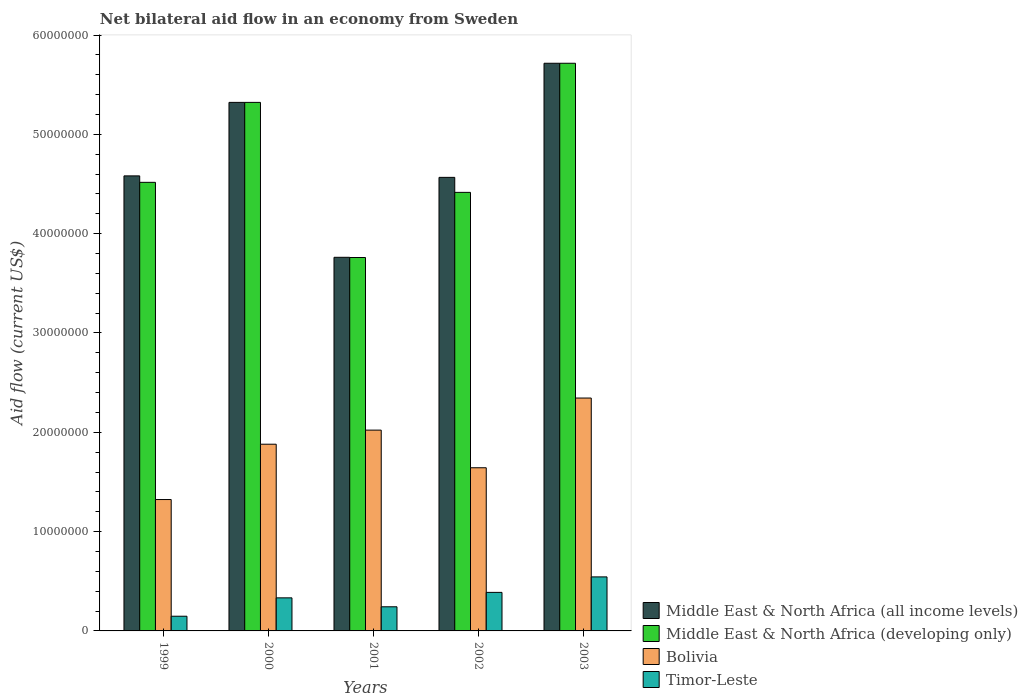How many groups of bars are there?
Make the answer very short. 5. Are the number of bars per tick equal to the number of legend labels?
Ensure brevity in your answer.  Yes. Are the number of bars on each tick of the X-axis equal?
Ensure brevity in your answer.  Yes. How many bars are there on the 3rd tick from the left?
Provide a succinct answer. 4. How many bars are there on the 5th tick from the right?
Keep it short and to the point. 4. What is the label of the 1st group of bars from the left?
Your answer should be very brief. 1999. What is the net bilateral aid flow in Timor-Leste in 2000?
Offer a terse response. 3.33e+06. Across all years, what is the maximum net bilateral aid flow in Bolivia?
Ensure brevity in your answer.  2.34e+07. Across all years, what is the minimum net bilateral aid flow in Timor-Leste?
Your response must be concise. 1.48e+06. What is the total net bilateral aid flow in Middle East & North Africa (developing only) in the graph?
Provide a succinct answer. 2.37e+08. What is the difference between the net bilateral aid flow in Middle East & North Africa (all income levels) in 1999 and that in 2003?
Provide a short and direct response. -1.13e+07. What is the difference between the net bilateral aid flow in Timor-Leste in 2003 and the net bilateral aid flow in Bolivia in 2001?
Make the answer very short. -1.48e+07. What is the average net bilateral aid flow in Timor-Leste per year?
Your response must be concise. 3.31e+06. In the year 2000, what is the difference between the net bilateral aid flow in Bolivia and net bilateral aid flow in Timor-Leste?
Give a very brief answer. 1.55e+07. In how many years, is the net bilateral aid flow in Middle East & North Africa (all income levels) greater than 8000000 US$?
Provide a short and direct response. 5. What is the ratio of the net bilateral aid flow in Timor-Leste in 1999 to that in 2001?
Ensure brevity in your answer.  0.61. Is the difference between the net bilateral aid flow in Bolivia in 1999 and 2000 greater than the difference between the net bilateral aid flow in Timor-Leste in 1999 and 2000?
Your answer should be compact. No. What is the difference between the highest and the second highest net bilateral aid flow in Middle East & North Africa (developing only)?
Your response must be concise. 3.94e+06. What is the difference between the highest and the lowest net bilateral aid flow in Middle East & North Africa (all income levels)?
Offer a very short reply. 1.95e+07. In how many years, is the net bilateral aid flow in Middle East & North Africa (all income levels) greater than the average net bilateral aid flow in Middle East & North Africa (all income levels) taken over all years?
Your response must be concise. 2. What does the 1st bar from the left in 2003 represents?
Provide a short and direct response. Middle East & North Africa (all income levels). What does the 4th bar from the right in 2003 represents?
Offer a very short reply. Middle East & North Africa (all income levels). Is it the case that in every year, the sum of the net bilateral aid flow in Middle East & North Africa (developing only) and net bilateral aid flow in Timor-Leste is greater than the net bilateral aid flow in Middle East & North Africa (all income levels)?
Your answer should be very brief. Yes. What is the difference between two consecutive major ticks on the Y-axis?
Make the answer very short. 1.00e+07. Does the graph contain grids?
Provide a succinct answer. No. How many legend labels are there?
Provide a short and direct response. 4. What is the title of the graph?
Your response must be concise. Net bilateral aid flow in an economy from Sweden. What is the label or title of the X-axis?
Keep it short and to the point. Years. What is the Aid flow (current US$) in Middle East & North Africa (all income levels) in 1999?
Your response must be concise. 4.58e+07. What is the Aid flow (current US$) in Middle East & North Africa (developing only) in 1999?
Keep it short and to the point. 4.52e+07. What is the Aid flow (current US$) of Bolivia in 1999?
Make the answer very short. 1.32e+07. What is the Aid flow (current US$) of Timor-Leste in 1999?
Provide a short and direct response. 1.48e+06. What is the Aid flow (current US$) of Middle East & North Africa (all income levels) in 2000?
Give a very brief answer. 5.32e+07. What is the Aid flow (current US$) of Middle East & North Africa (developing only) in 2000?
Make the answer very short. 5.32e+07. What is the Aid flow (current US$) in Bolivia in 2000?
Give a very brief answer. 1.88e+07. What is the Aid flow (current US$) of Timor-Leste in 2000?
Provide a succinct answer. 3.33e+06. What is the Aid flow (current US$) in Middle East & North Africa (all income levels) in 2001?
Keep it short and to the point. 3.76e+07. What is the Aid flow (current US$) of Middle East & North Africa (developing only) in 2001?
Your answer should be compact. 3.76e+07. What is the Aid flow (current US$) in Bolivia in 2001?
Provide a short and direct response. 2.02e+07. What is the Aid flow (current US$) of Timor-Leste in 2001?
Your answer should be compact. 2.43e+06. What is the Aid flow (current US$) in Middle East & North Africa (all income levels) in 2002?
Provide a succinct answer. 4.57e+07. What is the Aid flow (current US$) of Middle East & North Africa (developing only) in 2002?
Keep it short and to the point. 4.42e+07. What is the Aid flow (current US$) of Bolivia in 2002?
Provide a short and direct response. 1.64e+07. What is the Aid flow (current US$) in Timor-Leste in 2002?
Your answer should be very brief. 3.88e+06. What is the Aid flow (current US$) of Middle East & North Africa (all income levels) in 2003?
Make the answer very short. 5.72e+07. What is the Aid flow (current US$) in Middle East & North Africa (developing only) in 2003?
Your answer should be very brief. 5.72e+07. What is the Aid flow (current US$) in Bolivia in 2003?
Your answer should be compact. 2.34e+07. What is the Aid flow (current US$) of Timor-Leste in 2003?
Your response must be concise. 5.44e+06. Across all years, what is the maximum Aid flow (current US$) of Middle East & North Africa (all income levels)?
Offer a terse response. 5.72e+07. Across all years, what is the maximum Aid flow (current US$) of Middle East & North Africa (developing only)?
Your answer should be very brief. 5.72e+07. Across all years, what is the maximum Aid flow (current US$) in Bolivia?
Ensure brevity in your answer.  2.34e+07. Across all years, what is the maximum Aid flow (current US$) of Timor-Leste?
Offer a very short reply. 5.44e+06. Across all years, what is the minimum Aid flow (current US$) in Middle East & North Africa (all income levels)?
Offer a very short reply. 3.76e+07. Across all years, what is the minimum Aid flow (current US$) of Middle East & North Africa (developing only)?
Provide a short and direct response. 3.76e+07. Across all years, what is the minimum Aid flow (current US$) of Bolivia?
Offer a terse response. 1.32e+07. Across all years, what is the minimum Aid flow (current US$) of Timor-Leste?
Your answer should be very brief. 1.48e+06. What is the total Aid flow (current US$) of Middle East & North Africa (all income levels) in the graph?
Your answer should be compact. 2.39e+08. What is the total Aid flow (current US$) of Middle East & North Africa (developing only) in the graph?
Provide a short and direct response. 2.37e+08. What is the total Aid flow (current US$) of Bolivia in the graph?
Offer a terse response. 9.21e+07. What is the total Aid flow (current US$) in Timor-Leste in the graph?
Give a very brief answer. 1.66e+07. What is the difference between the Aid flow (current US$) in Middle East & North Africa (all income levels) in 1999 and that in 2000?
Your answer should be compact. -7.40e+06. What is the difference between the Aid flow (current US$) in Middle East & North Africa (developing only) in 1999 and that in 2000?
Make the answer very short. -8.05e+06. What is the difference between the Aid flow (current US$) in Bolivia in 1999 and that in 2000?
Offer a very short reply. -5.57e+06. What is the difference between the Aid flow (current US$) in Timor-Leste in 1999 and that in 2000?
Your answer should be compact. -1.85e+06. What is the difference between the Aid flow (current US$) in Middle East & North Africa (all income levels) in 1999 and that in 2001?
Ensure brevity in your answer.  8.20e+06. What is the difference between the Aid flow (current US$) of Middle East & North Africa (developing only) in 1999 and that in 2001?
Ensure brevity in your answer.  7.57e+06. What is the difference between the Aid flow (current US$) in Bolivia in 1999 and that in 2001?
Offer a terse response. -6.99e+06. What is the difference between the Aid flow (current US$) in Timor-Leste in 1999 and that in 2001?
Offer a very short reply. -9.50e+05. What is the difference between the Aid flow (current US$) of Middle East & North Africa (all income levels) in 1999 and that in 2002?
Your answer should be compact. 1.50e+05. What is the difference between the Aid flow (current US$) of Middle East & North Africa (developing only) in 1999 and that in 2002?
Keep it short and to the point. 1.01e+06. What is the difference between the Aid flow (current US$) in Bolivia in 1999 and that in 2002?
Your answer should be very brief. -3.20e+06. What is the difference between the Aid flow (current US$) in Timor-Leste in 1999 and that in 2002?
Your answer should be compact. -2.40e+06. What is the difference between the Aid flow (current US$) in Middle East & North Africa (all income levels) in 1999 and that in 2003?
Provide a succinct answer. -1.13e+07. What is the difference between the Aid flow (current US$) in Middle East & North Africa (developing only) in 1999 and that in 2003?
Your answer should be compact. -1.20e+07. What is the difference between the Aid flow (current US$) in Bolivia in 1999 and that in 2003?
Your answer should be very brief. -1.02e+07. What is the difference between the Aid flow (current US$) of Timor-Leste in 1999 and that in 2003?
Give a very brief answer. -3.96e+06. What is the difference between the Aid flow (current US$) of Middle East & North Africa (all income levels) in 2000 and that in 2001?
Your answer should be very brief. 1.56e+07. What is the difference between the Aid flow (current US$) in Middle East & North Africa (developing only) in 2000 and that in 2001?
Ensure brevity in your answer.  1.56e+07. What is the difference between the Aid flow (current US$) in Bolivia in 2000 and that in 2001?
Your answer should be very brief. -1.42e+06. What is the difference between the Aid flow (current US$) of Middle East & North Africa (all income levels) in 2000 and that in 2002?
Provide a short and direct response. 7.55e+06. What is the difference between the Aid flow (current US$) of Middle East & North Africa (developing only) in 2000 and that in 2002?
Keep it short and to the point. 9.06e+06. What is the difference between the Aid flow (current US$) in Bolivia in 2000 and that in 2002?
Keep it short and to the point. 2.37e+06. What is the difference between the Aid flow (current US$) of Timor-Leste in 2000 and that in 2002?
Your response must be concise. -5.50e+05. What is the difference between the Aid flow (current US$) of Middle East & North Africa (all income levels) in 2000 and that in 2003?
Provide a short and direct response. -3.94e+06. What is the difference between the Aid flow (current US$) of Middle East & North Africa (developing only) in 2000 and that in 2003?
Make the answer very short. -3.94e+06. What is the difference between the Aid flow (current US$) of Bolivia in 2000 and that in 2003?
Make the answer very short. -4.65e+06. What is the difference between the Aid flow (current US$) of Timor-Leste in 2000 and that in 2003?
Ensure brevity in your answer.  -2.11e+06. What is the difference between the Aid flow (current US$) of Middle East & North Africa (all income levels) in 2001 and that in 2002?
Give a very brief answer. -8.05e+06. What is the difference between the Aid flow (current US$) of Middle East & North Africa (developing only) in 2001 and that in 2002?
Your answer should be compact. -6.56e+06. What is the difference between the Aid flow (current US$) in Bolivia in 2001 and that in 2002?
Your response must be concise. 3.79e+06. What is the difference between the Aid flow (current US$) in Timor-Leste in 2001 and that in 2002?
Offer a very short reply. -1.45e+06. What is the difference between the Aid flow (current US$) of Middle East & North Africa (all income levels) in 2001 and that in 2003?
Provide a succinct answer. -1.95e+07. What is the difference between the Aid flow (current US$) of Middle East & North Africa (developing only) in 2001 and that in 2003?
Your answer should be compact. -1.96e+07. What is the difference between the Aid flow (current US$) of Bolivia in 2001 and that in 2003?
Offer a terse response. -3.23e+06. What is the difference between the Aid flow (current US$) of Timor-Leste in 2001 and that in 2003?
Offer a terse response. -3.01e+06. What is the difference between the Aid flow (current US$) in Middle East & North Africa (all income levels) in 2002 and that in 2003?
Your answer should be very brief. -1.15e+07. What is the difference between the Aid flow (current US$) of Middle East & North Africa (developing only) in 2002 and that in 2003?
Make the answer very short. -1.30e+07. What is the difference between the Aid flow (current US$) of Bolivia in 2002 and that in 2003?
Offer a very short reply. -7.02e+06. What is the difference between the Aid flow (current US$) in Timor-Leste in 2002 and that in 2003?
Provide a succinct answer. -1.56e+06. What is the difference between the Aid flow (current US$) of Middle East & North Africa (all income levels) in 1999 and the Aid flow (current US$) of Middle East & North Africa (developing only) in 2000?
Your answer should be compact. -7.40e+06. What is the difference between the Aid flow (current US$) in Middle East & North Africa (all income levels) in 1999 and the Aid flow (current US$) in Bolivia in 2000?
Provide a succinct answer. 2.70e+07. What is the difference between the Aid flow (current US$) in Middle East & North Africa (all income levels) in 1999 and the Aid flow (current US$) in Timor-Leste in 2000?
Offer a terse response. 4.25e+07. What is the difference between the Aid flow (current US$) in Middle East & North Africa (developing only) in 1999 and the Aid flow (current US$) in Bolivia in 2000?
Make the answer very short. 2.64e+07. What is the difference between the Aid flow (current US$) of Middle East & North Africa (developing only) in 1999 and the Aid flow (current US$) of Timor-Leste in 2000?
Your answer should be compact. 4.18e+07. What is the difference between the Aid flow (current US$) of Bolivia in 1999 and the Aid flow (current US$) of Timor-Leste in 2000?
Your answer should be very brief. 9.90e+06. What is the difference between the Aid flow (current US$) in Middle East & North Africa (all income levels) in 1999 and the Aid flow (current US$) in Middle East & North Africa (developing only) in 2001?
Offer a very short reply. 8.22e+06. What is the difference between the Aid flow (current US$) of Middle East & North Africa (all income levels) in 1999 and the Aid flow (current US$) of Bolivia in 2001?
Offer a very short reply. 2.56e+07. What is the difference between the Aid flow (current US$) of Middle East & North Africa (all income levels) in 1999 and the Aid flow (current US$) of Timor-Leste in 2001?
Offer a terse response. 4.34e+07. What is the difference between the Aid flow (current US$) in Middle East & North Africa (developing only) in 1999 and the Aid flow (current US$) in Bolivia in 2001?
Keep it short and to the point. 2.50e+07. What is the difference between the Aid flow (current US$) in Middle East & North Africa (developing only) in 1999 and the Aid flow (current US$) in Timor-Leste in 2001?
Your response must be concise. 4.27e+07. What is the difference between the Aid flow (current US$) in Bolivia in 1999 and the Aid flow (current US$) in Timor-Leste in 2001?
Offer a very short reply. 1.08e+07. What is the difference between the Aid flow (current US$) of Middle East & North Africa (all income levels) in 1999 and the Aid flow (current US$) of Middle East & North Africa (developing only) in 2002?
Make the answer very short. 1.66e+06. What is the difference between the Aid flow (current US$) of Middle East & North Africa (all income levels) in 1999 and the Aid flow (current US$) of Bolivia in 2002?
Provide a succinct answer. 2.94e+07. What is the difference between the Aid flow (current US$) in Middle East & North Africa (all income levels) in 1999 and the Aid flow (current US$) in Timor-Leste in 2002?
Offer a very short reply. 4.19e+07. What is the difference between the Aid flow (current US$) in Middle East & North Africa (developing only) in 1999 and the Aid flow (current US$) in Bolivia in 2002?
Your answer should be compact. 2.87e+07. What is the difference between the Aid flow (current US$) in Middle East & North Africa (developing only) in 1999 and the Aid flow (current US$) in Timor-Leste in 2002?
Offer a terse response. 4.13e+07. What is the difference between the Aid flow (current US$) in Bolivia in 1999 and the Aid flow (current US$) in Timor-Leste in 2002?
Your response must be concise. 9.35e+06. What is the difference between the Aid flow (current US$) of Middle East & North Africa (all income levels) in 1999 and the Aid flow (current US$) of Middle East & North Africa (developing only) in 2003?
Ensure brevity in your answer.  -1.13e+07. What is the difference between the Aid flow (current US$) of Middle East & North Africa (all income levels) in 1999 and the Aid flow (current US$) of Bolivia in 2003?
Your answer should be very brief. 2.24e+07. What is the difference between the Aid flow (current US$) in Middle East & North Africa (all income levels) in 1999 and the Aid flow (current US$) in Timor-Leste in 2003?
Your response must be concise. 4.04e+07. What is the difference between the Aid flow (current US$) of Middle East & North Africa (developing only) in 1999 and the Aid flow (current US$) of Bolivia in 2003?
Provide a short and direct response. 2.17e+07. What is the difference between the Aid flow (current US$) in Middle East & North Africa (developing only) in 1999 and the Aid flow (current US$) in Timor-Leste in 2003?
Provide a succinct answer. 3.97e+07. What is the difference between the Aid flow (current US$) of Bolivia in 1999 and the Aid flow (current US$) of Timor-Leste in 2003?
Make the answer very short. 7.79e+06. What is the difference between the Aid flow (current US$) in Middle East & North Africa (all income levels) in 2000 and the Aid flow (current US$) in Middle East & North Africa (developing only) in 2001?
Ensure brevity in your answer.  1.56e+07. What is the difference between the Aid flow (current US$) of Middle East & North Africa (all income levels) in 2000 and the Aid flow (current US$) of Bolivia in 2001?
Your response must be concise. 3.30e+07. What is the difference between the Aid flow (current US$) of Middle East & North Africa (all income levels) in 2000 and the Aid flow (current US$) of Timor-Leste in 2001?
Offer a very short reply. 5.08e+07. What is the difference between the Aid flow (current US$) in Middle East & North Africa (developing only) in 2000 and the Aid flow (current US$) in Bolivia in 2001?
Offer a terse response. 3.30e+07. What is the difference between the Aid flow (current US$) in Middle East & North Africa (developing only) in 2000 and the Aid flow (current US$) in Timor-Leste in 2001?
Provide a short and direct response. 5.08e+07. What is the difference between the Aid flow (current US$) of Bolivia in 2000 and the Aid flow (current US$) of Timor-Leste in 2001?
Provide a succinct answer. 1.64e+07. What is the difference between the Aid flow (current US$) of Middle East & North Africa (all income levels) in 2000 and the Aid flow (current US$) of Middle East & North Africa (developing only) in 2002?
Your answer should be very brief. 9.06e+06. What is the difference between the Aid flow (current US$) in Middle East & North Africa (all income levels) in 2000 and the Aid flow (current US$) in Bolivia in 2002?
Offer a terse response. 3.68e+07. What is the difference between the Aid flow (current US$) of Middle East & North Africa (all income levels) in 2000 and the Aid flow (current US$) of Timor-Leste in 2002?
Make the answer very short. 4.93e+07. What is the difference between the Aid flow (current US$) in Middle East & North Africa (developing only) in 2000 and the Aid flow (current US$) in Bolivia in 2002?
Your answer should be compact. 3.68e+07. What is the difference between the Aid flow (current US$) in Middle East & North Africa (developing only) in 2000 and the Aid flow (current US$) in Timor-Leste in 2002?
Your answer should be very brief. 4.93e+07. What is the difference between the Aid flow (current US$) of Bolivia in 2000 and the Aid flow (current US$) of Timor-Leste in 2002?
Keep it short and to the point. 1.49e+07. What is the difference between the Aid flow (current US$) in Middle East & North Africa (all income levels) in 2000 and the Aid flow (current US$) in Middle East & North Africa (developing only) in 2003?
Provide a short and direct response. -3.94e+06. What is the difference between the Aid flow (current US$) in Middle East & North Africa (all income levels) in 2000 and the Aid flow (current US$) in Bolivia in 2003?
Provide a succinct answer. 2.98e+07. What is the difference between the Aid flow (current US$) of Middle East & North Africa (all income levels) in 2000 and the Aid flow (current US$) of Timor-Leste in 2003?
Make the answer very short. 4.78e+07. What is the difference between the Aid flow (current US$) of Middle East & North Africa (developing only) in 2000 and the Aid flow (current US$) of Bolivia in 2003?
Ensure brevity in your answer.  2.98e+07. What is the difference between the Aid flow (current US$) in Middle East & North Africa (developing only) in 2000 and the Aid flow (current US$) in Timor-Leste in 2003?
Offer a terse response. 4.78e+07. What is the difference between the Aid flow (current US$) in Bolivia in 2000 and the Aid flow (current US$) in Timor-Leste in 2003?
Give a very brief answer. 1.34e+07. What is the difference between the Aid flow (current US$) of Middle East & North Africa (all income levels) in 2001 and the Aid flow (current US$) of Middle East & North Africa (developing only) in 2002?
Provide a succinct answer. -6.54e+06. What is the difference between the Aid flow (current US$) of Middle East & North Africa (all income levels) in 2001 and the Aid flow (current US$) of Bolivia in 2002?
Offer a terse response. 2.12e+07. What is the difference between the Aid flow (current US$) of Middle East & North Africa (all income levels) in 2001 and the Aid flow (current US$) of Timor-Leste in 2002?
Your answer should be compact. 3.37e+07. What is the difference between the Aid flow (current US$) in Middle East & North Africa (developing only) in 2001 and the Aid flow (current US$) in Bolivia in 2002?
Your answer should be very brief. 2.12e+07. What is the difference between the Aid flow (current US$) in Middle East & North Africa (developing only) in 2001 and the Aid flow (current US$) in Timor-Leste in 2002?
Offer a very short reply. 3.37e+07. What is the difference between the Aid flow (current US$) of Bolivia in 2001 and the Aid flow (current US$) of Timor-Leste in 2002?
Provide a short and direct response. 1.63e+07. What is the difference between the Aid flow (current US$) in Middle East & North Africa (all income levels) in 2001 and the Aid flow (current US$) in Middle East & North Africa (developing only) in 2003?
Your answer should be very brief. -1.95e+07. What is the difference between the Aid flow (current US$) of Middle East & North Africa (all income levels) in 2001 and the Aid flow (current US$) of Bolivia in 2003?
Your response must be concise. 1.42e+07. What is the difference between the Aid flow (current US$) of Middle East & North Africa (all income levels) in 2001 and the Aid flow (current US$) of Timor-Leste in 2003?
Your response must be concise. 3.22e+07. What is the difference between the Aid flow (current US$) in Middle East & North Africa (developing only) in 2001 and the Aid flow (current US$) in Bolivia in 2003?
Provide a succinct answer. 1.42e+07. What is the difference between the Aid flow (current US$) in Middle East & North Africa (developing only) in 2001 and the Aid flow (current US$) in Timor-Leste in 2003?
Keep it short and to the point. 3.22e+07. What is the difference between the Aid flow (current US$) in Bolivia in 2001 and the Aid flow (current US$) in Timor-Leste in 2003?
Provide a succinct answer. 1.48e+07. What is the difference between the Aid flow (current US$) in Middle East & North Africa (all income levels) in 2002 and the Aid flow (current US$) in Middle East & North Africa (developing only) in 2003?
Keep it short and to the point. -1.15e+07. What is the difference between the Aid flow (current US$) in Middle East & North Africa (all income levels) in 2002 and the Aid flow (current US$) in Bolivia in 2003?
Your answer should be very brief. 2.22e+07. What is the difference between the Aid flow (current US$) in Middle East & North Africa (all income levels) in 2002 and the Aid flow (current US$) in Timor-Leste in 2003?
Your answer should be compact. 4.02e+07. What is the difference between the Aid flow (current US$) in Middle East & North Africa (developing only) in 2002 and the Aid flow (current US$) in Bolivia in 2003?
Make the answer very short. 2.07e+07. What is the difference between the Aid flow (current US$) in Middle East & North Africa (developing only) in 2002 and the Aid flow (current US$) in Timor-Leste in 2003?
Your answer should be compact. 3.87e+07. What is the difference between the Aid flow (current US$) of Bolivia in 2002 and the Aid flow (current US$) of Timor-Leste in 2003?
Give a very brief answer. 1.10e+07. What is the average Aid flow (current US$) of Middle East & North Africa (all income levels) per year?
Your answer should be very brief. 4.79e+07. What is the average Aid flow (current US$) in Middle East & North Africa (developing only) per year?
Your answer should be very brief. 4.75e+07. What is the average Aid flow (current US$) in Bolivia per year?
Ensure brevity in your answer.  1.84e+07. What is the average Aid flow (current US$) in Timor-Leste per year?
Offer a terse response. 3.31e+06. In the year 1999, what is the difference between the Aid flow (current US$) of Middle East & North Africa (all income levels) and Aid flow (current US$) of Middle East & North Africa (developing only)?
Ensure brevity in your answer.  6.50e+05. In the year 1999, what is the difference between the Aid flow (current US$) in Middle East & North Africa (all income levels) and Aid flow (current US$) in Bolivia?
Provide a succinct answer. 3.26e+07. In the year 1999, what is the difference between the Aid flow (current US$) of Middle East & North Africa (all income levels) and Aid flow (current US$) of Timor-Leste?
Offer a terse response. 4.43e+07. In the year 1999, what is the difference between the Aid flow (current US$) of Middle East & North Africa (developing only) and Aid flow (current US$) of Bolivia?
Your answer should be compact. 3.19e+07. In the year 1999, what is the difference between the Aid flow (current US$) in Middle East & North Africa (developing only) and Aid flow (current US$) in Timor-Leste?
Offer a terse response. 4.37e+07. In the year 1999, what is the difference between the Aid flow (current US$) in Bolivia and Aid flow (current US$) in Timor-Leste?
Ensure brevity in your answer.  1.18e+07. In the year 2000, what is the difference between the Aid flow (current US$) in Middle East & North Africa (all income levels) and Aid flow (current US$) in Bolivia?
Offer a terse response. 3.44e+07. In the year 2000, what is the difference between the Aid flow (current US$) in Middle East & North Africa (all income levels) and Aid flow (current US$) in Timor-Leste?
Your answer should be very brief. 4.99e+07. In the year 2000, what is the difference between the Aid flow (current US$) of Middle East & North Africa (developing only) and Aid flow (current US$) of Bolivia?
Your answer should be very brief. 3.44e+07. In the year 2000, what is the difference between the Aid flow (current US$) of Middle East & North Africa (developing only) and Aid flow (current US$) of Timor-Leste?
Ensure brevity in your answer.  4.99e+07. In the year 2000, what is the difference between the Aid flow (current US$) in Bolivia and Aid flow (current US$) in Timor-Leste?
Offer a terse response. 1.55e+07. In the year 2001, what is the difference between the Aid flow (current US$) in Middle East & North Africa (all income levels) and Aid flow (current US$) in Bolivia?
Offer a terse response. 1.74e+07. In the year 2001, what is the difference between the Aid flow (current US$) in Middle East & North Africa (all income levels) and Aid flow (current US$) in Timor-Leste?
Provide a succinct answer. 3.52e+07. In the year 2001, what is the difference between the Aid flow (current US$) of Middle East & North Africa (developing only) and Aid flow (current US$) of Bolivia?
Provide a succinct answer. 1.74e+07. In the year 2001, what is the difference between the Aid flow (current US$) of Middle East & North Africa (developing only) and Aid flow (current US$) of Timor-Leste?
Ensure brevity in your answer.  3.52e+07. In the year 2001, what is the difference between the Aid flow (current US$) of Bolivia and Aid flow (current US$) of Timor-Leste?
Give a very brief answer. 1.78e+07. In the year 2002, what is the difference between the Aid flow (current US$) of Middle East & North Africa (all income levels) and Aid flow (current US$) of Middle East & North Africa (developing only)?
Your answer should be compact. 1.51e+06. In the year 2002, what is the difference between the Aid flow (current US$) in Middle East & North Africa (all income levels) and Aid flow (current US$) in Bolivia?
Provide a succinct answer. 2.92e+07. In the year 2002, what is the difference between the Aid flow (current US$) in Middle East & North Africa (all income levels) and Aid flow (current US$) in Timor-Leste?
Your response must be concise. 4.18e+07. In the year 2002, what is the difference between the Aid flow (current US$) of Middle East & North Africa (developing only) and Aid flow (current US$) of Bolivia?
Make the answer very short. 2.77e+07. In the year 2002, what is the difference between the Aid flow (current US$) in Middle East & North Africa (developing only) and Aid flow (current US$) in Timor-Leste?
Offer a terse response. 4.03e+07. In the year 2002, what is the difference between the Aid flow (current US$) of Bolivia and Aid flow (current US$) of Timor-Leste?
Offer a terse response. 1.26e+07. In the year 2003, what is the difference between the Aid flow (current US$) of Middle East & North Africa (all income levels) and Aid flow (current US$) of Middle East & North Africa (developing only)?
Your answer should be compact. 0. In the year 2003, what is the difference between the Aid flow (current US$) in Middle East & North Africa (all income levels) and Aid flow (current US$) in Bolivia?
Provide a succinct answer. 3.37e+07. In the year 2003, what is the difference between the Aid flow (current US$) of Middle East & North Africa (all income levels) and Aid flow (current US$) of Timor-Leste?
Provide a short and direct response. 5.17e+07. In the year 2003, what is the difference between the Aid flow (current US$) in Middle East & North Africa (developing only) and Aid flow (current US$) in Bolivia?
Ensure brevity in your answer.  3.37e+07. In the year 2003, what is the difference between the Aid flow (current US$) of Middle East & North Africa (developing only) and Aid flow (current US$) of Timor-Leste?
Keep it short and to the point. 5.17e+07. In the year 2003, what is the difference between the Aid flow (current US$) of Bolivia and Aid flow (current US$) of Timor-Leste?
Keep it short and to the point. 1.80e+07. What is the ratio of the Aid flow (current US$) in Middle East & North Africa (all income levels) in 1999 to that in 2000?
Ensure brevity in your answer.  0.86. What is the ratio of the Aid flow (current US$) in Middle East & North Africa (developing only) in 1999 to that in 2000?
Offer a very short reply. 0.85. What is the ratio of the Aid flow (current US$) in Bolivia in 1999 to that in 2000?
Your answer should be compact. 0.7. What is the ratio of the Aid flow (current US$) of Timor-Leste in 1999 to that in 2000?
Offer a terse response. 0.44. What is the ratio of the Aid flow (current US$) of Middle East & North Africa (all income levels) in 1999 to that in 2001?
Your response must be concise. 1.22. What is the ratio of the Aid flow (current US$) of Middle East & North Africa (developing only) in 1999 to that in 2001?
Provide a succinct answer. 1.2. What is the ratio of the Aid flow (current US$) in Bolivia in 1999 to that in 2001?
Your answer should be compact. 0.65. What is the ratio of the Aid flow (current US$) of Timor-Leste in 1999 to that in 2001?
Give a very brief answer. 0.61. What is the ratio of the Aid flow (current US$) in Middle East & North Africa (all income levels) in 1999 to that in 2002?
Keep it short and to the point. 1. What is the ratio of the Aid flow (current US$) in Middle East & North Africa (developing only) in 1999 to that in 2002?
Offer a terse response. 1.02. What is the ratio of the Aid flow (current US$) of Bolivia in 1999 to that in 2002?
Keep it short and to the point. 0.81. What is the ratio of the Aid flow (current US$) in Timor-Leste in 1999 to that in 2002?
Provide a short and direct response. 0.38. What is the ratio of the Aid flow (current US$) of Middle East & North Africa (all income levels) in 1999 to that in 2003?
Make the answer very short. 0.8. What is the ratio of the Aid flow (current US$) in Middle East & North Africa (developing only) in 1999 to that in 2003?
Your answer should be very brief. 0.79. What is the ratio of the Aid flow (current US$) in Bolivia in 1999 to that in 2003?
Provide a succinct answer. 0.56. What is the ratio of the Aid flow (current US$) in Timor-Leste in 1999 to that in 2003?
Your response must be concise. 0.27. What is the ratio of the Aid flow (current US$) of Middle East & North Africa (all income levels) in 2000 to that in 2001?
Your answer should be very brief. 1.41. What is the ratio of the Aid flow (current US$) of Middle East & North Africa (developing only) in 2000 to that in 2001?
Ensure brevity in your answer.  1.42. What is the ratio of the Aid flow (current US$) of Bolivia in 2000 to that in 2001?
Offer a terse response. 0.93. What is the ratio of the Aid flow (current US$) in Timor-Leste in 2000 to that in 2001?
Ensure brevity in your answer.  1.37. What is the ratio of the Aid flow (current US$) in Middle East & North Africa (all income levels) in 2000 to that in 2002?
Offer a terse response. 1.17. What is the ratio of the Aid flow (current US$) in Middle East & North Africa (developing only) in 2000 to that in 2002?
Provide a succinct answer. 1.21. What is the ratio of the Aid flow (current US$) of Bolivia in 2000 to that in 2002?
Offer a terse response. 1.14. What is the ratio of the Aid flow (current US$) in Timor-Leste in 2000 to that in 2002?
Provide a succinct answer. 0.86. What is the ratio of the Aid flow (current US$) in Middle East & North Africa (all income levels) in 2000 to that in 2003?
Offer a very short reply. 0.93. What is the ratio of the Aid flow (current US$) of Middle East & North Africa (developing only) in 2000 to that in 2003?
Offer a terse response. 0.93. What is the ratio of the Aid flow (current US$) in Bolivia in 2000 to that in 2003?
Make the answer very short. 0.8. What is the ratio of the Aid flow (current US$) in Timor-Leste in 2000 to that in 2003?
Provide a short and direct response. 0.61. What is the ratio of the Aid flow (current US$) in Middle East & North Africa (all income levels) in 2001 to that in 2002?
Make the answer very short. 0.82. What is the ratio of the Aid flow (current US$) in Middle East & North Africa (developing only) in 2001 to that in 2002?
Offer a very short reply. 0.85. What is the ratio of the Aid flow (current US$) of Bolivia in 2001 to that in 2002?
Provide a succinct answer. 1.23. What is the ratio of the Aid flow (current US$) in Timor-Leste in 2001 to that in 2002?
Your answer should be compact. 0.63. What is the ratio of the Aid flow (current US$) in Middle East & North Africa (all income levels) in 2001 to that in 2003?
Keep it short and to the point. 0.66. What is the ratio of the Aid flow (current US$) in Middle East & North Africa (developing only) in 2001 to that in 2003?
Provide a succinct answer. 0.66. What is the ratio of the Aid flow (current US$) in Bolivia in 2001 to that in 2003?
Your response must be concise. 0.86. What is the ratio of the Aid flow (current US$) in Timor-Leste in 2001 to that in 2003?
Give a very brief answer. 0.45. What is the ratio of the Aid flow (current US$) in Middle East & North Africa (all income levels) in 2002 to that in 2003?
Provide a succinct answer. 0.8. What is the ratio of the Aid flow (current US$) of Middle East & North Africa (developing only) in 2002 to that in 2003?
Make the answer very short. 0.77. What is the ratio of the Aid flow (current US$) of Bolivia in 2002 to that in 2003?
Your answer should be very brief. 0.7. What is the ratio of the Aid flow (current US$) in Timor-Leste in 2002 to that in 2003?
Your answer should be very brief. 0.71. What is the difference between the highest and the second highest Aid flow (current US$) in Middle East & North Africa (all income levels)?
Make the answer very short. 3.94e+06. What is the difference between the highest and the second highest Aid flow (current US$) of Middle East & North Africa (developing only)?
Provide a succinct answer. 3.94e+06. What is the difference between the highest and the second highest Aid flow (current US$) in Bolivia?
Offer a very short reply. 3.23e+06. What is the difference between the highest and the second highest Aid flow (current US$) in Timor-Leste?
Provide a short and direct response. 1.56e+06. What is the difference between the highest and the lowest Aid flow (current US$) in Middle East & North Africa (all income levels)?
Your response must be concise. 1.95e+07. What is the difference between the highest and the lowest Aid flow (current US$) of Middle East & North Africa (developing only)?
Your answer should be very brief. 1.96e+07. What is the difference between the highest and the lowest Aid flow (current US$) of Bolivia?
Your answer should be compact. 1.02e+07. What is the difference between the highest and the lowest Aid flow (current US$) of Timor-Leste?
Provide a succinct answer. 3.96e+06. 